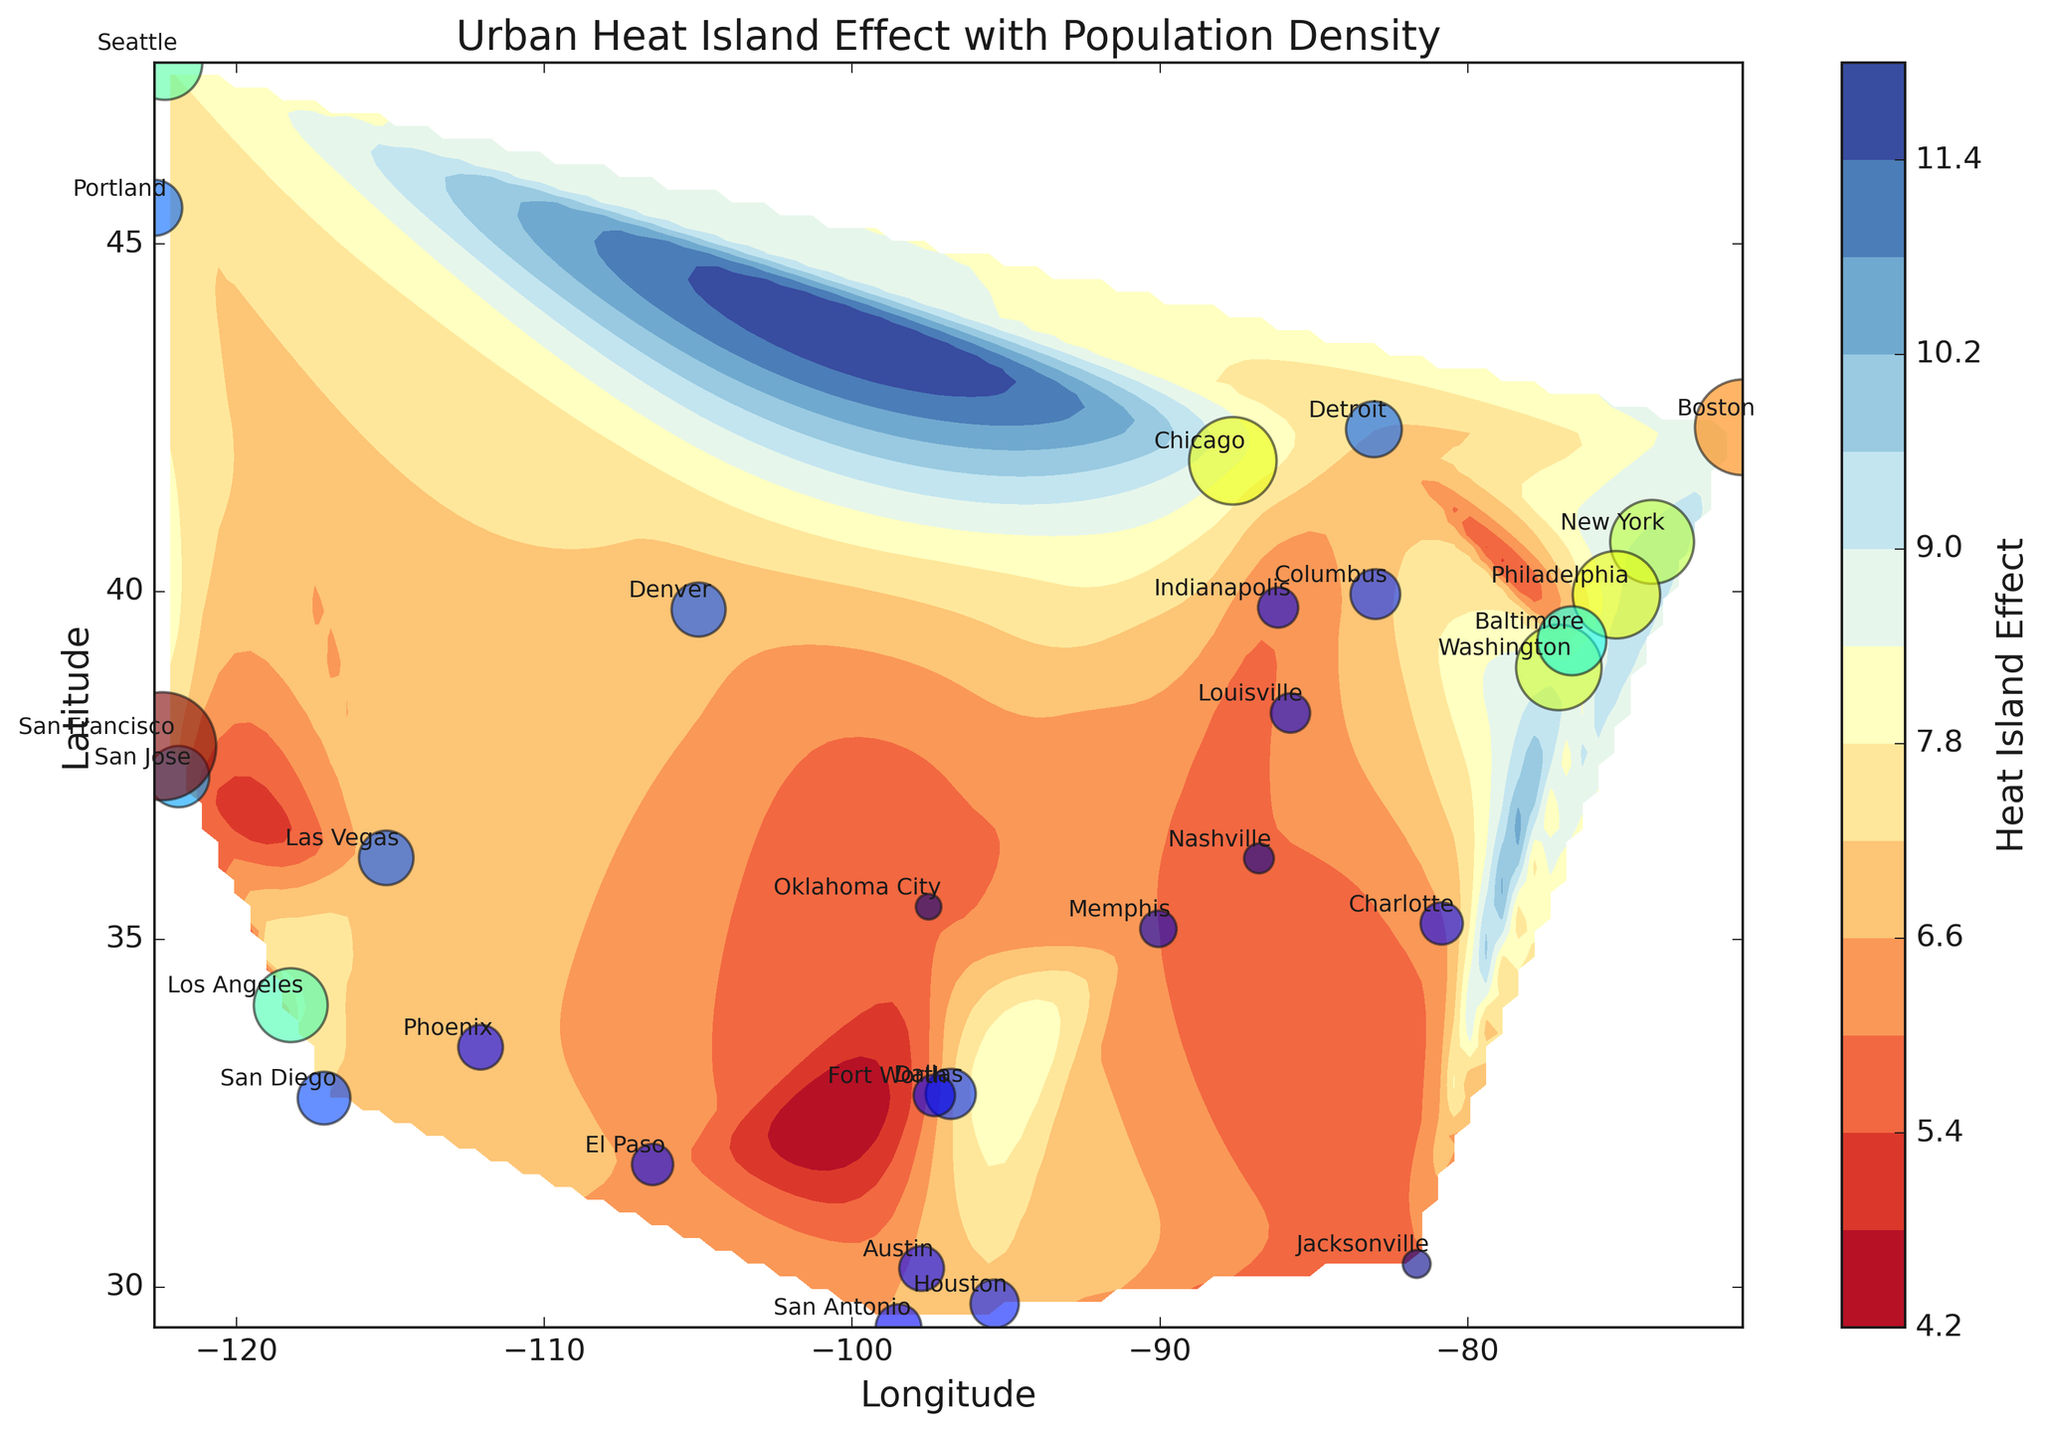What is the city with the highest urban heat island effect? Look at the color bar and contour plot to identify the city with the darkest red area. Then, cross-reference the positions with city labels.
Answer: New York Which two cities have a very similar population density but differ significantly in their heat island effects? Compare the sizes of the scatter plot markers (population density) and the colors of the contour areas (heat island effect). Find cities with nearly equal marker sizes but different colors.
Answer: San Francisco and Boston How does the population density of Chicago compare to Philadelphia and what can you infer about their heat island effects? Compare the sizes of the markers for Chicago and Philadelphia. Check the heat island effect values using the contour colors around these markers. Chicago has a slightly higher population density and both have high heat island effects.
Answer: Chicago has slightly higher density, both high effects What general trend can you observe about the relationship between population density and heat island effect in this figure? Notice the general color of the contour areas around larger markers and compare it to smaller markers. Generally, higher-density cities tend to have higher heat island effects (darker colors like red and orange).
Answer: Higher density, higher effect Which city in the plot has the lowest population density, and what is its heat island effect? Look for the smallest (visually smallest) scatter plot marker and identify the city it corresponds to. Cross-reference the heat island color in that area.
Answer: Oklahoma City, 5.8 Which city has the highest density but a lower-than-expected heat island effect based on its population density? Look for cities with very large markers but contour areas that are lighter (not red).
Answer: San Francisco What are the heat island effects for Denver and Seattle, and how do they compare? Identify both cities on the scatter plot and observe the contour colors around them. Denver's color is lighter than Seattle's which has a dark contour. Denver has a heat island effect of 6.9, and Seattle has 7.8; Seattle's effect is higher.
Answer: Denver 6.9, Seattle 7.8; Seattle is higher Name two cities in the plot that have both low population density and low heat island effects. Look for the cities with the smallest markers (low population density) and light-colored contour areas. Identify two such cities.
Answer: Oklahoma City, Nashville By looking at the visual spread, which coast (East or West) has cities with generally higher population densities and heat island effects? Compare the scatter plot markers and contour tones of cities located on the East coast vs. the West coast. The East coast tends to have larger markers and darker colors, indicating higher density and heat effects.
Answer: East coast Which city with a heat island effect above 8.0 has the lowest population density? Identify the cities from the contour plot with colors representing a heat island effect above 8.0, then find which one among those has the smallest scatter plot marker.
Answer: Washington 